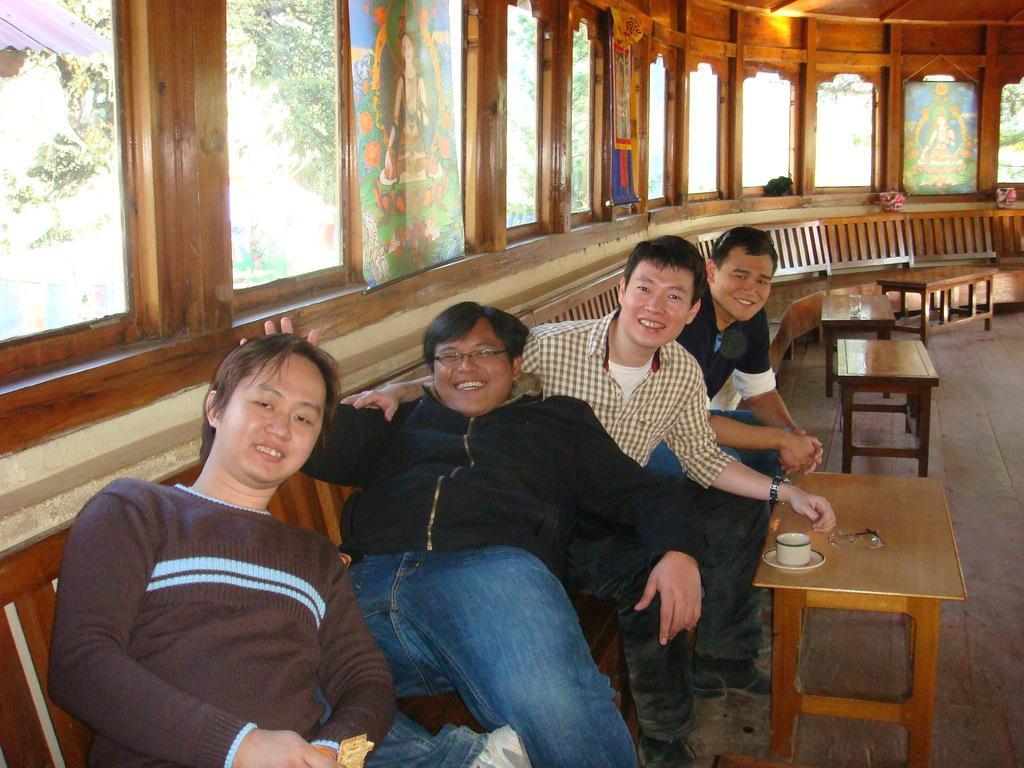In one or two sentences, can you explain what this image depicts? there are four person sitting on a chair with table in front of them 